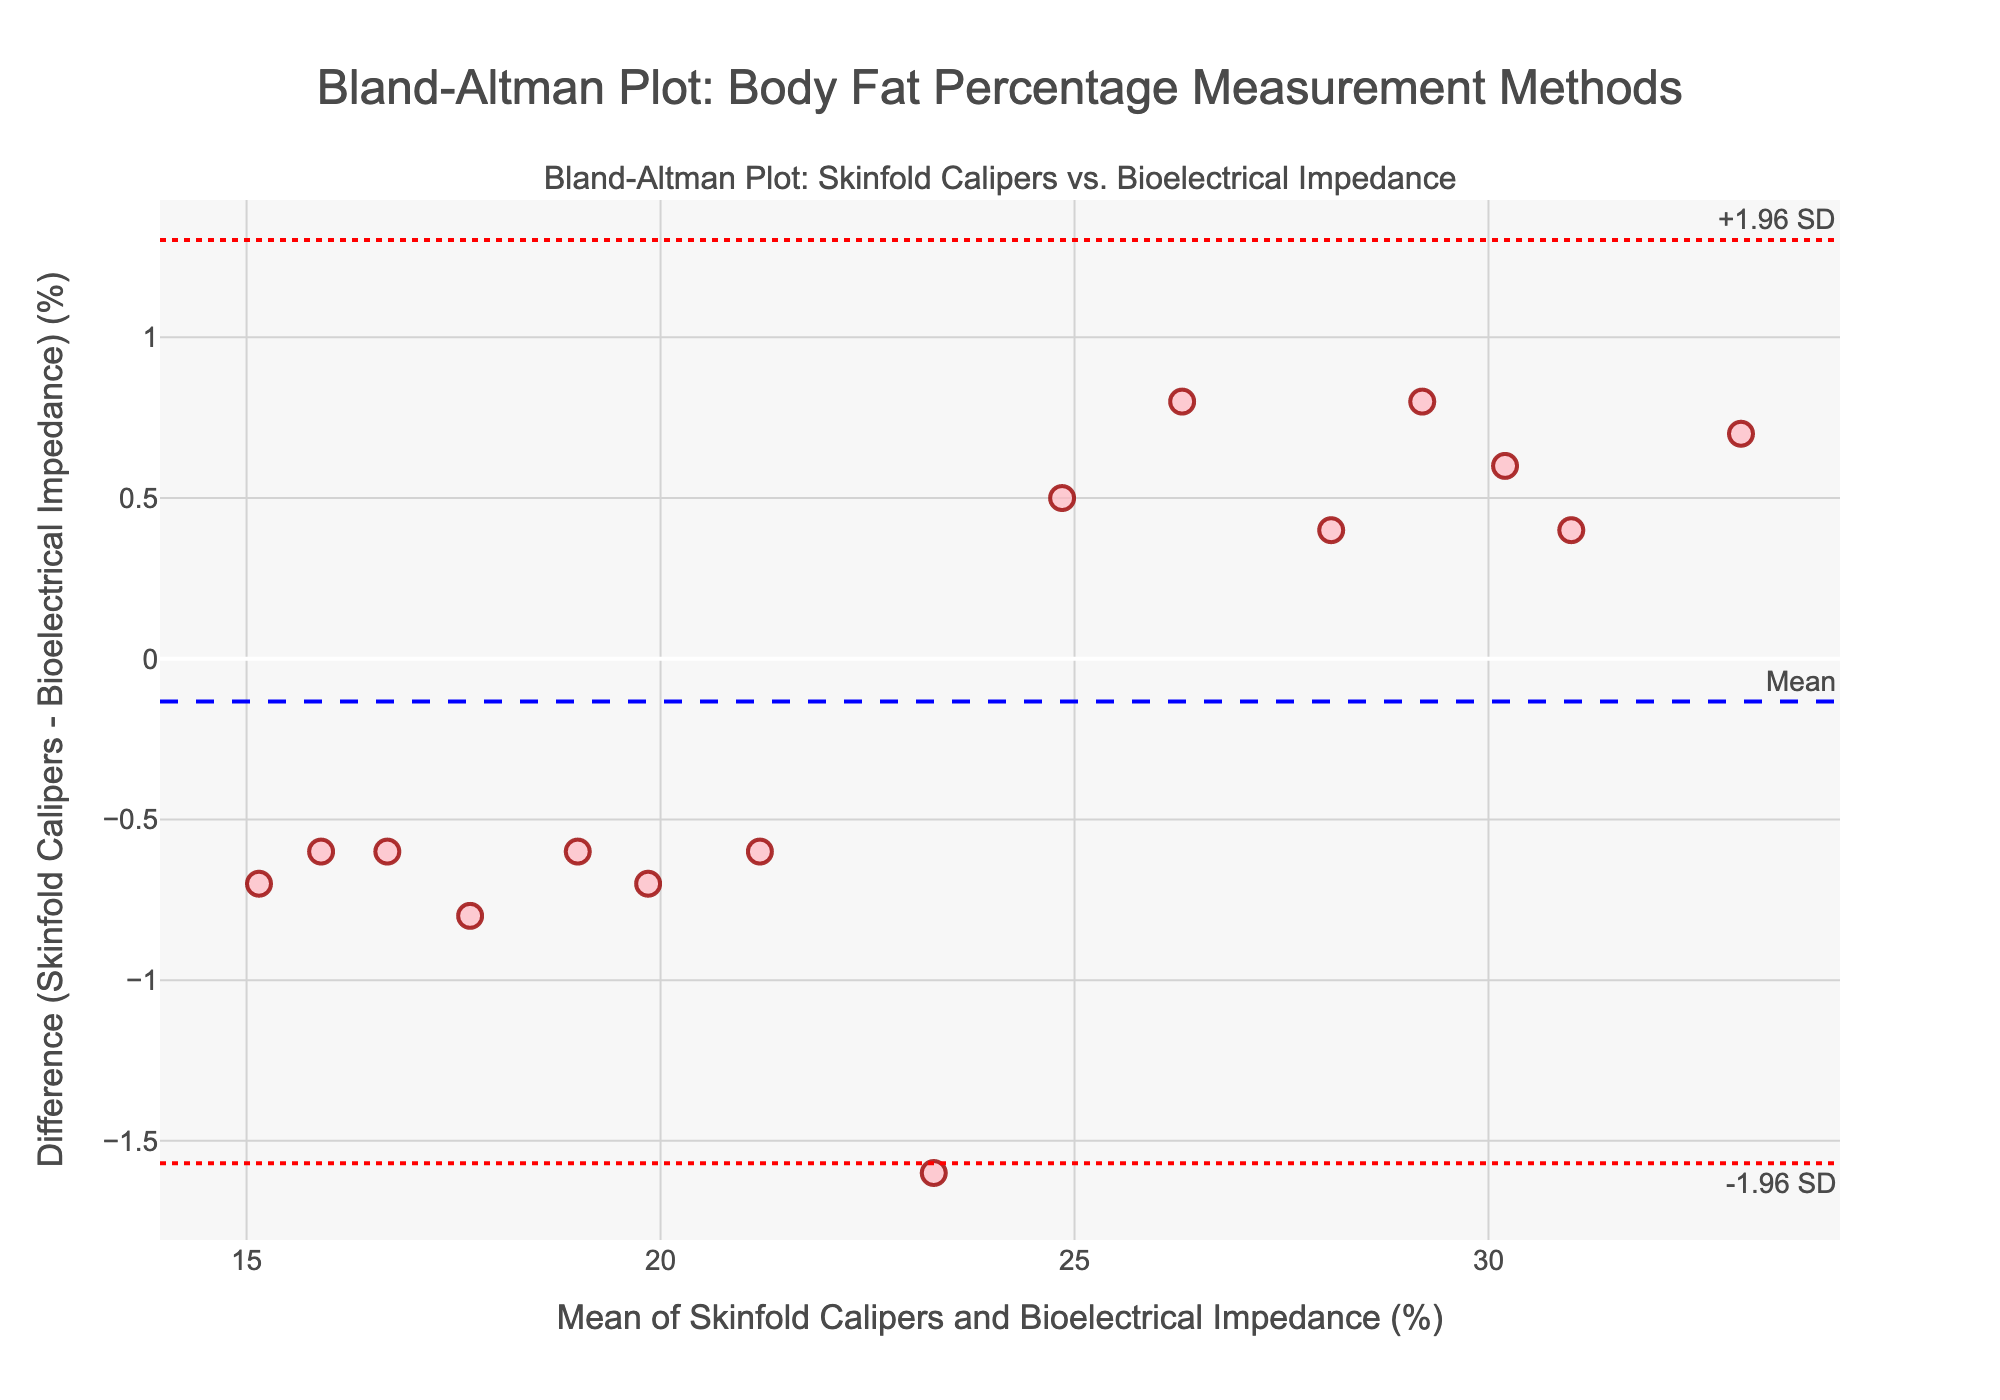What is the title of the plot? The title of the plot is located at the top and is usually the largest text. It reads: "Bland-Altman Plot: Body Fat Percentage Measurement Methods."
Answer: Bland-Altman Plot: Body Fat Percentage Measurement Methods What does the x-axis represent? The x-axis title is written below the horizontal line and it reads: "Mean of Skinfold Calipers and Bioelectrical Impedance (%)."
Answer: Mean of Skinfold Calipers and Bioelectrical Impedance (%) What does the y-axis represent? The y-axis title is written next to the vertical line and it reads: "Difference (Skinfold Calipers - Bioelectrical Impedance) (%)."
Answer: Difference (Skinfold Calipers - Bioelectrical Impedance) (%) What is the mean difference line labeled as? The mean difference line is indicated by a blue dashed line passing horizontally through the plot, and it is labeled "Mean" on the top right.
Answer: Mean Where are the limits of agreement lines located? There are two red dotted lines: one labeled "+1.96 SD" which is located towards the top right, and the other labeled "-1.96 SD" situated towards the bottom right.
Answer: +1.96 SD at the top and -1.96 SD at the bottom How does Sophia's data point compare to the mean difference? To find Sophia's data point, identify her measurement differences and compare them to the difference indicated by the blue dashed line (Mean). Sophia's difference is positive, and it sits above the mean difference line on the plot.
Answer: Above the mean difference Which data point has the highest difference value? Look for the point farthest from the x-axis vertically. Identify its corresponding mean on the x-axis and refer back to the data. The highest difference value belongs to Sophia.
Answer: Sophia What is the range of differences between Skinfold Calipers and Bioelectrical Impedance measurements? The range is determined by the highest and lowest points on the y-axis line, which are at approximately +1.96 SD and -1.96 SD, respectively.
Answer: From about -2 to +2 (%) Which data points fall outside the limits of agreement? Check the scatter plot for any data points outside the red dotted lines marked +1.96 SD and -1.96 SD. None of the points fall outside these limits.
Answer: None Do the differences tend to be higher or lower than the mean difference? Analyze if more points are above or below the mean difference line (blue dashed line). There appears to be a mix of points on both sides, but slightly more points might be above.
Answer: Slightly more above 